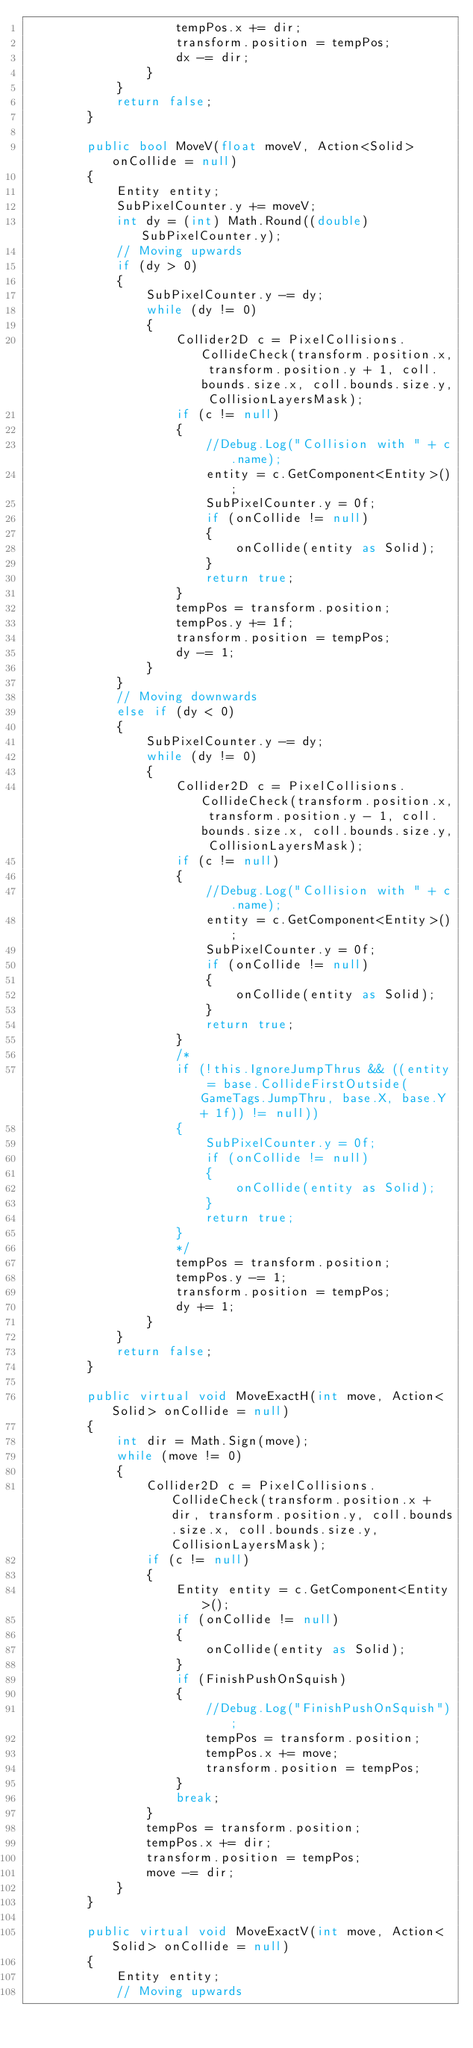<code> <loc_0><loc_0><loc_500><loc_500><_C#_>                    tempPos.x += dir;
                    transform.position = tempPos;
                    dx -= dir;
                }
            }
            return false;
        }

        public bool MoveV(float moveV, Action<Solid> onCollide = null)
        {
            Entity entity;
            SubPixelCounter.y += moveV;
            int dy = (int) Math.Round((double) SubPixelCounter.y);
            // Moving upwards
            if (dy > 0)
            {
                SubPixelCounter.y -= dy;
                while (dy != 0)
                {
                    Collider2D c = PixelCollisions.CollideCheck(transform.position.x, transform.position.y + 1, coll.bounds.size.x, coll.bounds.size.y, CollisionLayersMask);
                    if (c != null)
                    {
                        //Debug.Log("Collision with " + c.name);
                        entity = c.GetComponent<Entity>();
                        SubPixelCounter.y = 0f;
                        if (onCollide != null)
                        {
                            onCollide(entity as Solid);
                        }
                        return true;
                    }
                    tempPos = transform.position;
                    tempPos.y += 1f;
                    transform.position = tempPos;
                    dy -= 1;
                }
            }
            // Moving downwards
            else if (dy < 0)
            {
                SubPixelCounter.y -= dy;
                while (dy != 0)
                {
                    Collider2D c = PixelCollisions.CollideCheck(transform.position.x, transform.position.y - 1, coll.bounds.size.x, coll.bounds.size.y, CollisionLayersMask);
                    if (c != null)
                    {
                        //Debug.Log("Collision with " + c.name);
                        entity = c.GetComponent<Entity>();
                        SubPixelCounter.y = 0f;
                        if (onCollide != null)
                        {
                            onCollide(entity as Solid);
                        }
                        return true;
                    }
                    /*
                    if (!this.IgnoreJumpThrus && ((entity = base.CollideFirstOutside(GameTags.JumpThru, base.X, base.Y + 1f)) != null))
                    {
                        SubPixelCounter.y = 0f;
                        if (onCollide != null)
                        {
                            onCollide(entity as Solid);
                        }
                        return true;
                    }
                    */
                    tempPos = transform.position;
                    tempPos.y -= 1;
                    transform.position = tempPos;
                    dy += 1;
                }
            }
            return false;
        }

        public virtual void MoveExactH(int move, Action<Solid> onCollide = null)
        {
            int dir = Math.Sign(move);
            while (move != 0)
            {
                Collider2D c = PixelCollisions.CollideCheck(transform.position.x + dir, transform.position.y, coll.bounds.size.x, coll.bounds.size.y, CollisionLayersMask);
                if (c != null)
                {
                    Entity entity = c.GetComponent<Entity>();
                    if (onCollide != null)
                    {
                        onCollide(entity as Solid);
                    }
                    if (FinishPushOnSquish)
                    {
                        //Debug.Log("FinishPushOnSquish");
                        tempPos = transform.position;
                        tempPos.x += move;
                        transform.position = tempPos;
                    }
                    break;
                }
                tempPos = transform.position;
                tempPos.x += dir;
                transform.position = tempPos;
                move -= dir;
            }
        }

        public virtual void MoveExactV(int move, Action<Solid> onCollide = null)
        {
            Entity entity;
            // Moving upwards</code> 